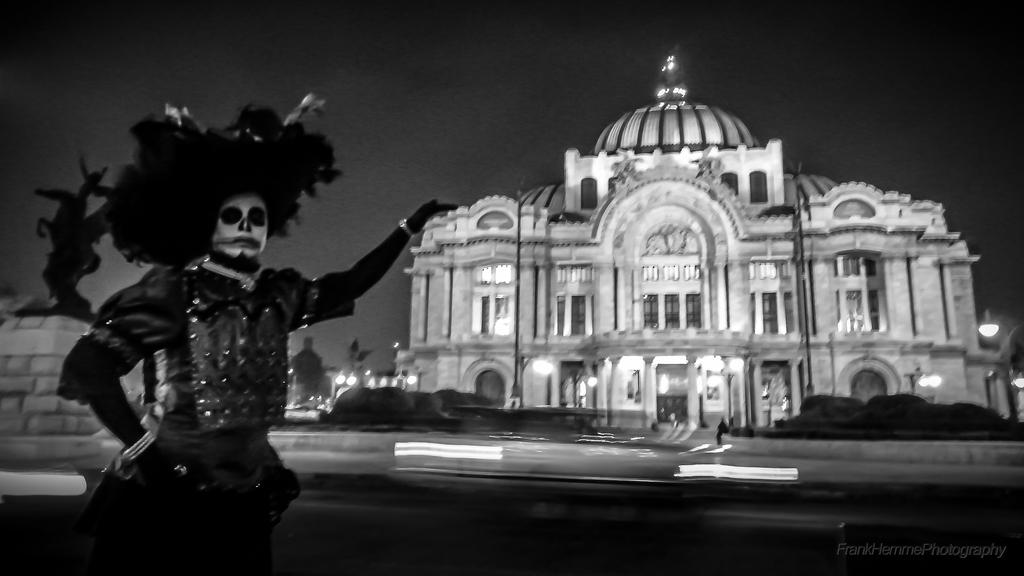What type of structure is visible in the image? There is a building in the image. What is the person in the image doing? The human is wearing costumes and standing in the image. What can be seen on the left side of the image? There is a statue on the left side of the image. What type of vegetation is present in the image? Trees and plants are visible in the image. What can be seen illuminating the area in the image? There are lights in the image. What are the poles used for in the image? The poles are present in the image, but their purpose is not specified. What type of throne is the person sitting on in the image? There is no throne present in the image; the person is standing and wearing costumes. What suggestion does the statue make in the image? The statue is not making any suggestions in the image; it is a stationary object. 